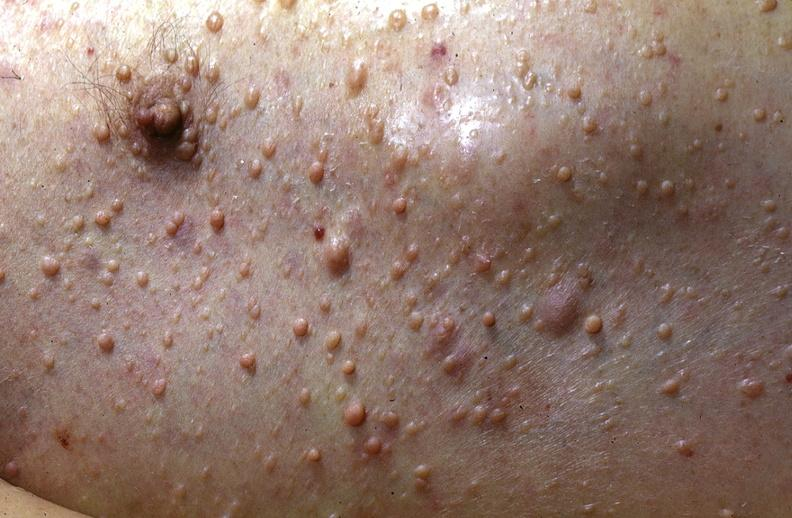what does this image show?
Answer the question using a single word or phrase. Skin 